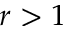<formula> <loc_0><loc_0><loc_500><loc_500>r > 1</formula> 